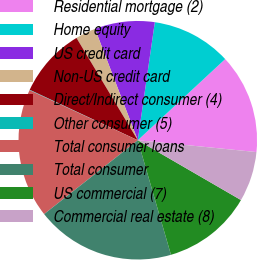Convert chart. <chart><loc_0><loc_0><loc_500><loc_500><pie_chart><fcel>Residential mortgage (2)<fcel>Home equity<fcel>US credit card<fcel>Non-US credit card<fcel>Direct/Indirect consumer (4)<fcel>Other consumer (5)<fcel>Total consumer loans<fcel>Total consumer<fcel>US commercial (7)<fcel>Commercial real estate (8)<nl><fcel>13.49%<fcel>10.81%<fcel>8.12%<fcel>2.75%<fcel>9.46%<fcel>0.06%<fcel>17.52%<fcel>18.86%<fcel>12.15%<fcel>6.78%<nl></chart> 